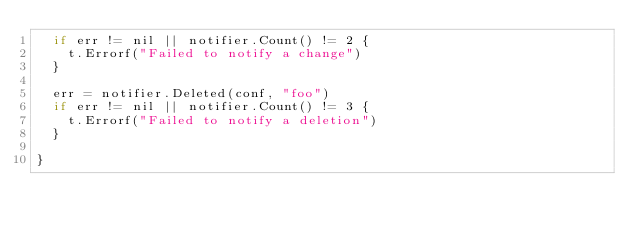Convert code to text. <code><loc_0><loc_0><loc_500><loc_500><_Go_>	if err != nil || notifier.Count() != 2 {
		t.Errorf("Failed to notify a change")
	}

	err = notifier.Deleted(conf, "foo")
	if err != nil || notifier.Count() != 3 {
		t.Errorf("Failed to notify a deletion")
	}

}
</code> 